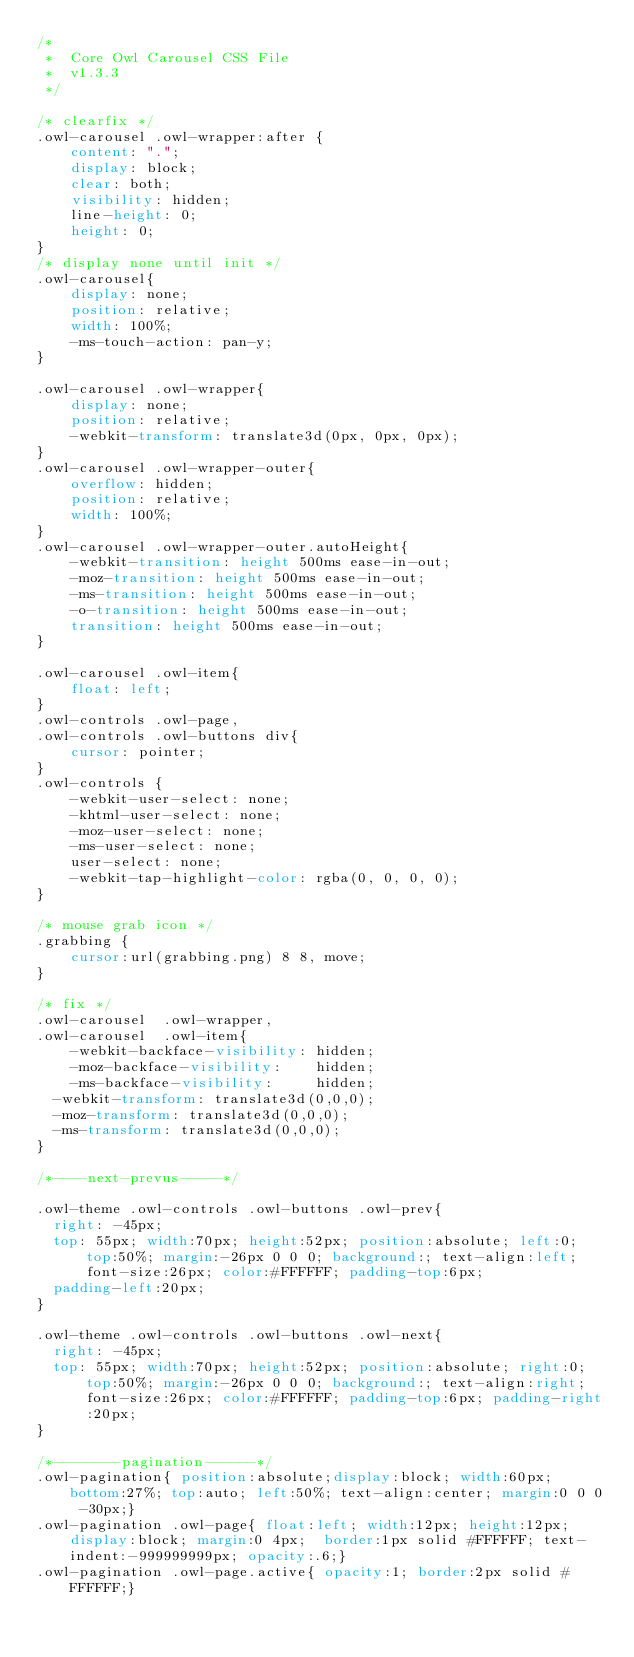<code> <loc_0><loc_0><loc_500><loc_500><_CSS_>/* 
 * 	Core Owl Carousel CSS File
 *	v1.3.3
 */

/* clearfix */
.owl-carousel .owl-wrapper:after {
	content: ".";
	display: block;
	clear: both;
	visibility: hidden;
	line-height: 0;
	height: 0;
}
/* display none until init */
.owl-carousel{
	display: none;
	position: relative;
	width: 100%;
	-ms-touch-action: pan-y;
}

.owl-carousel .owl-wrapper{
	display: none;
	position: relative;
	-webkit-transform: translate3d(0px, 0px, 0px);
}
.owl-carousel .owl-wrapper-outer{
	overflow: hidden;
	position: relative;
	width: 100%;
}
.owl-carousel .owl-wrapper-outer.autoHeight{
	-webkit-transition: height 500ms ease-in-out;
	-moz-transition: height 500ms ease-in-out;
	-ms-transition: height 500ms ease-in-out;
	-o-transition: height 500ms ease-in-out;
	transition: height 500ms ease-in-out;
}
	
.owl-carousel .owl-item{
	float: left;
}
.owl-controls .owl-page,
.owl-controls .owl-buttons div{
	cursor: pointer;
}
.owl-controls {
	-webkit-user-select: none;
	-khtml-user-select: none;
	-moz-user-select: none;
	-ms-user-select: none;
	user-select: none;
	-webkit-tap-highlight-color: rgba(0, 0, 0, 0);
}

/* mouse grab icon */
.grabbing { 
    cursor:url(grabbing.png) 8 8, move;
}

/* fix */
.owl-carousel  .owl-wrapper,
.owl-carousel  .owl-item{
	-webkit-backface-visibility: hidden;
	-moz-backface-visibility:    hidden;
	-ms-backface-visibility:     hidden;
  -webkit-transform: translate3d(0,0,0);
  -moz-transform: translate3d(0,0,0);
  -ms-transform: translate3d(0,0,0);
}

/*----next-prevus-----*/

.owl-theme .owl-controls .owl-buttons .owl-prev{
  right: -45px;
  top: 55px; width:70px; height:52px; position:absolute; left:0; top:50%; margin:-26px 0 0 0; background:; text-align:left; font-size:26px; color:#FFFFFF; padding-top:6px; 
  padding-left:20px;
}
 
.owl-theme .owl-controls .owl-buttons .owl-next{
  right: -45px;
  top: 55px; width:70px; height:52px; position:absolute; right:0; top:50%; margin:-26px 0 0 0; background:; text-align:right; font-size:26px; color:#FFFFFF; padding-top:6px; padding-right:20px;
}

/*--------pagination------*/
.owl-pagination{ position:absolute;display:block; width:60px; bottom:27%; top:auto; left:50%; text-align:center; margin:0 0 0 -30px;}
.owl-pagination .owl-page{ float:left; width:12px; height:12px; display:block; margin:0 4px;  border:1px solid #FFFFFF; text-indent:-999999999px; opacity:.6;}
.owl-pagination .owl-page.active{ opacity:1; border:2px solid #FFFFFF;}
</code> 